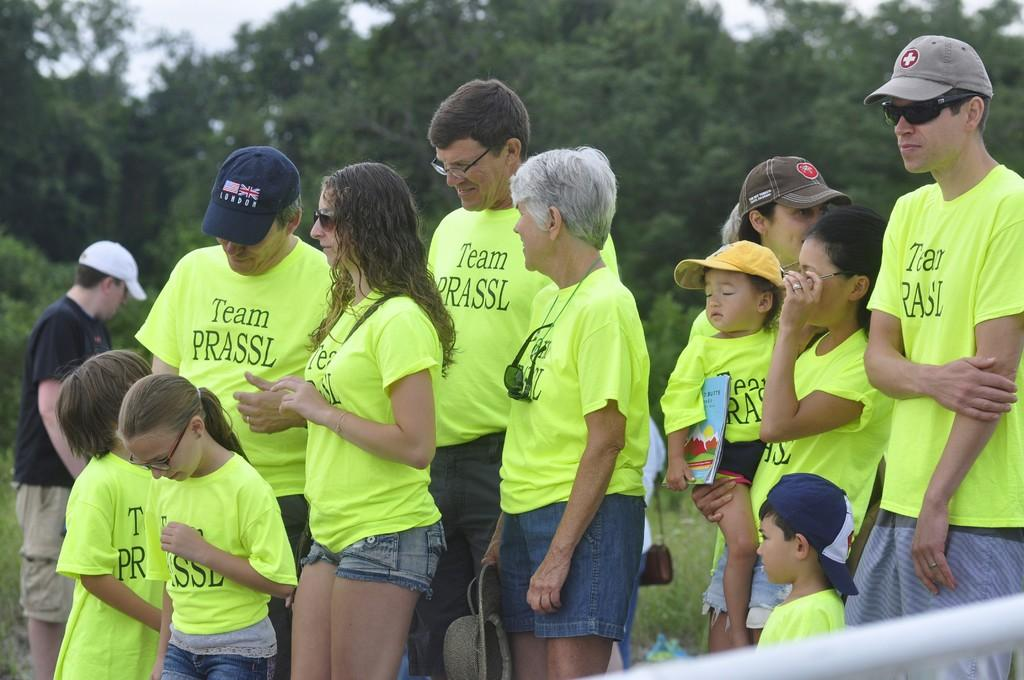What can be seen in the image? There are people standing in the image. What is visible in the background of the image? There are trees in the background of the image. What object is present at the bottom of the image? There is a rod at the bottom of the image. How many hands are visible in the image? The number of hands visible in the image cannot be determined from the provided facts, as we do not have information about the number of people or their body positions. 